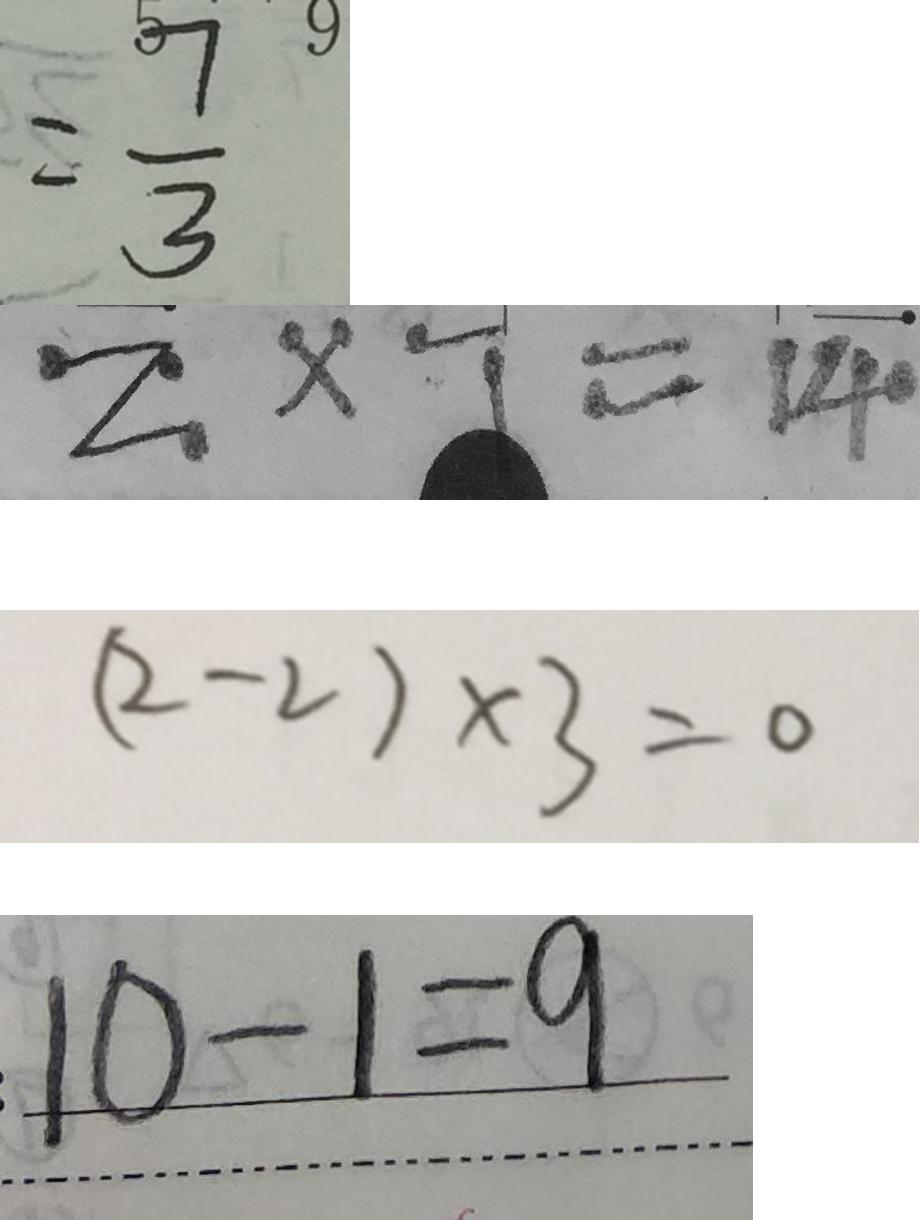Convert formula to latex. <formula><loc_0><loc_0><loc_500><loc_500>= \frac { 7 } { 3 } 
 2 \times 7 = 1 4 
 ( 2 - 2 ) \times 3 = 0 
 1 0 - 1 = 9</formula> 